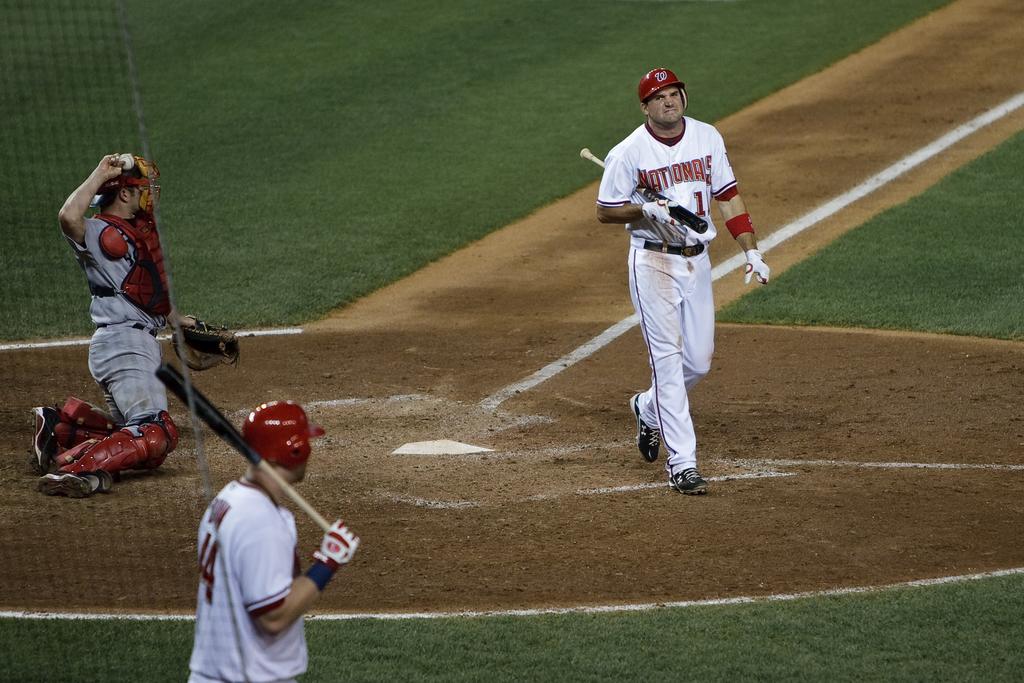What team does the batter play for?
Your answer should be compact. Nationals. What number is the batter jersey?
Ensure brevity in your answer.  1. 